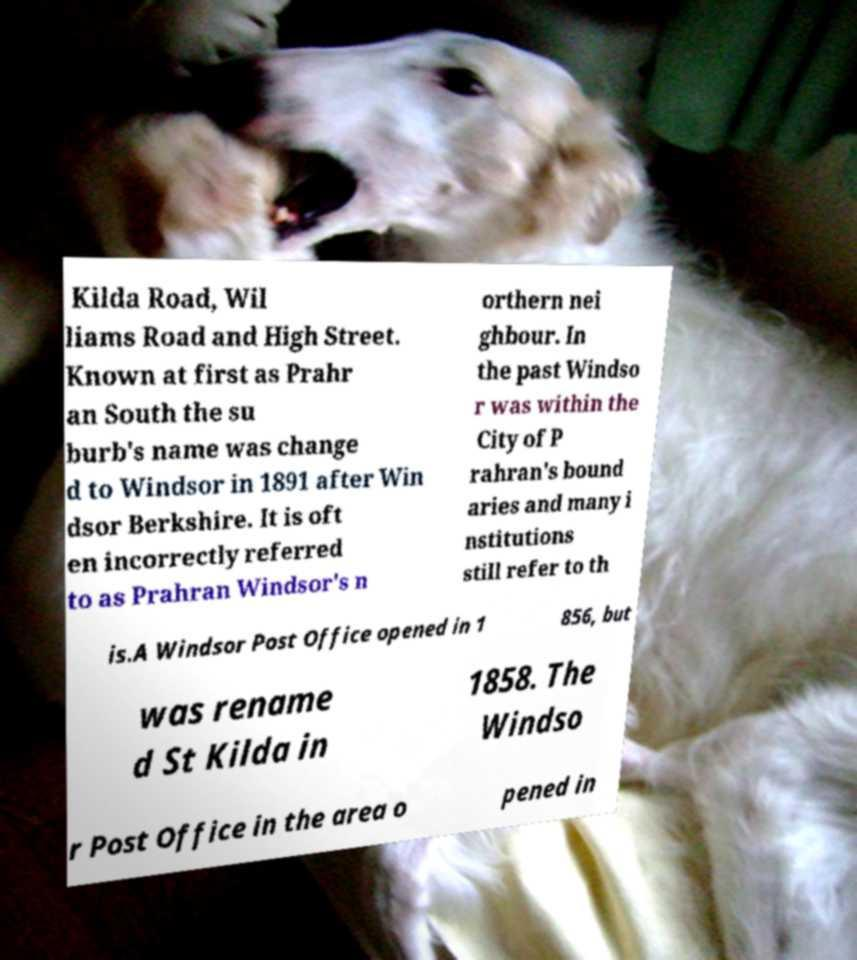There's text embedded in this image that I need extracted. Can you transcribe it verbatim? Kilda Road, Wil liams Road and High Street. Known at first as Prahr an South the su burb's name was change d to Windsor in 1891 after Win dsor Berkshire. It is oft en incorrectly referred to as Prahran Windsor's n orthern nei ghbour. In the past Windso r was within the City of P rahran's bound aries and many i nstitutions still refer to th is.A Windsor Post Office opened in 1 856, but was rename d St Kilda in 1858. The Windso r Post Office in the area o pened in 